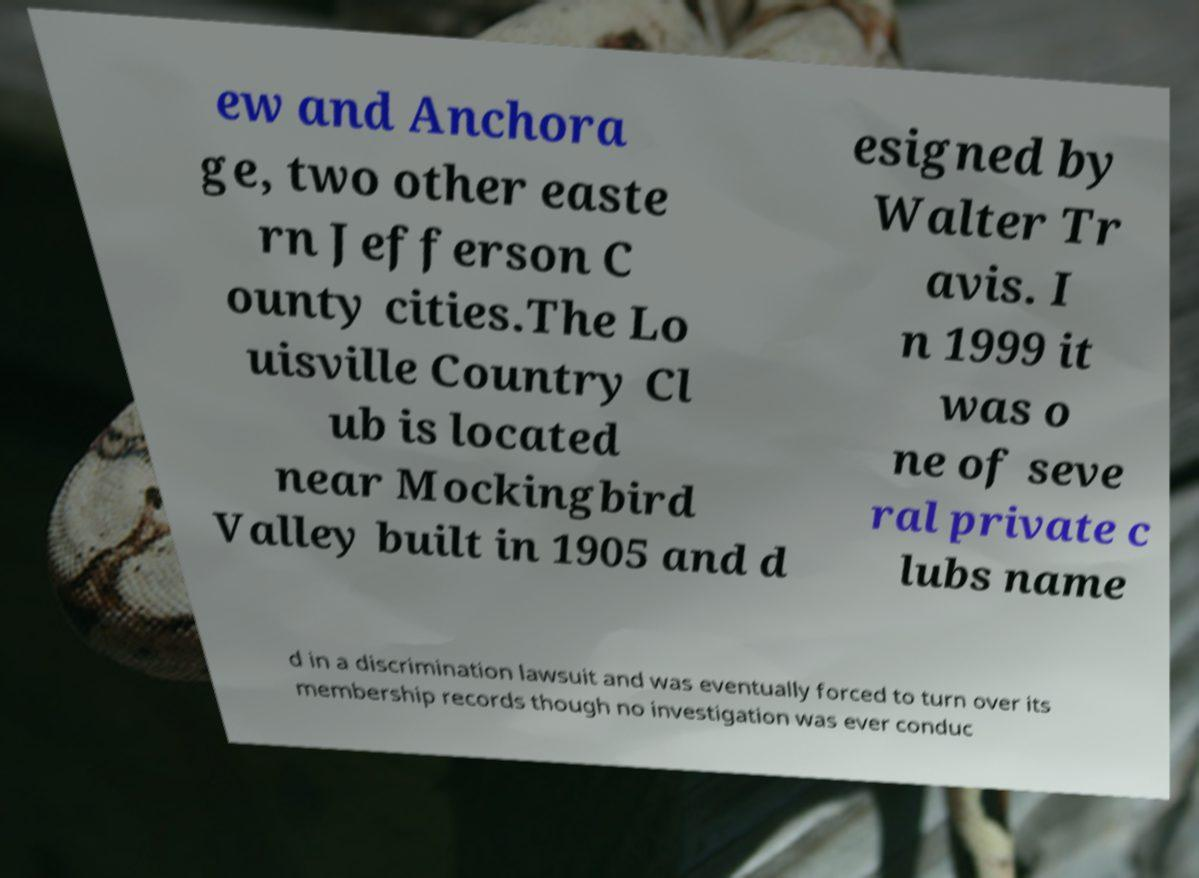For documentation purposes, I need the text within this image transcribed. Could you provide that? ew and Anchora ge, two other easte rn Jefferson C ounty cities.The Lo uisville Country Cl ub is located near Mockingbird Valley built in 1905 and d esigned by Walter Tr avis. I n 1999 it was o ne of seve ral private c lubs name d in a discrimination lawsuit and was eventually forced to turn over its membership records though no investigation was ever conduc 